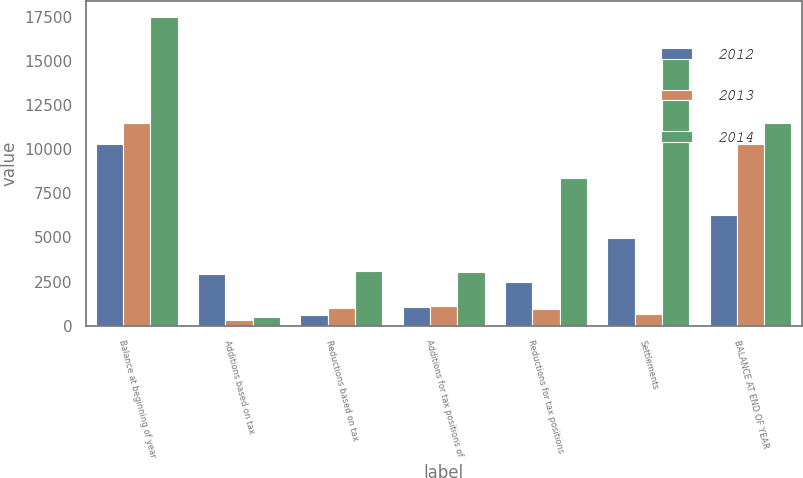Convert chart to OTSL. <chart><loc_0><loc_0><loc_500><loc_500><stacked_bar_chart><ecel><fcel>Balance at beginning of year<fcel>Additions based on tax<fcel>Reductions based on tax<fcel>Additions for tax positions of<fcel>Reductions for tax positions<fcel>Settlements<fcel>BALANCE AT END OF YEAR<nl><fcel>2012<fcel>10322<fcel>2940<fcel>581<fcel>1037<fcel>2495<fcel>4961<fcel>6262<nl><fcel>2013<fcel>11515<fcel>309<fcel>995<fcel>1090<fcel>959<fcel>638<fcel>10322<nl><fcel>2014<fcel>17524<fcel>499<fcel>3124<fcel>3032<fcel>8365<fcel>15475<fcel>11515<nl></chart> 